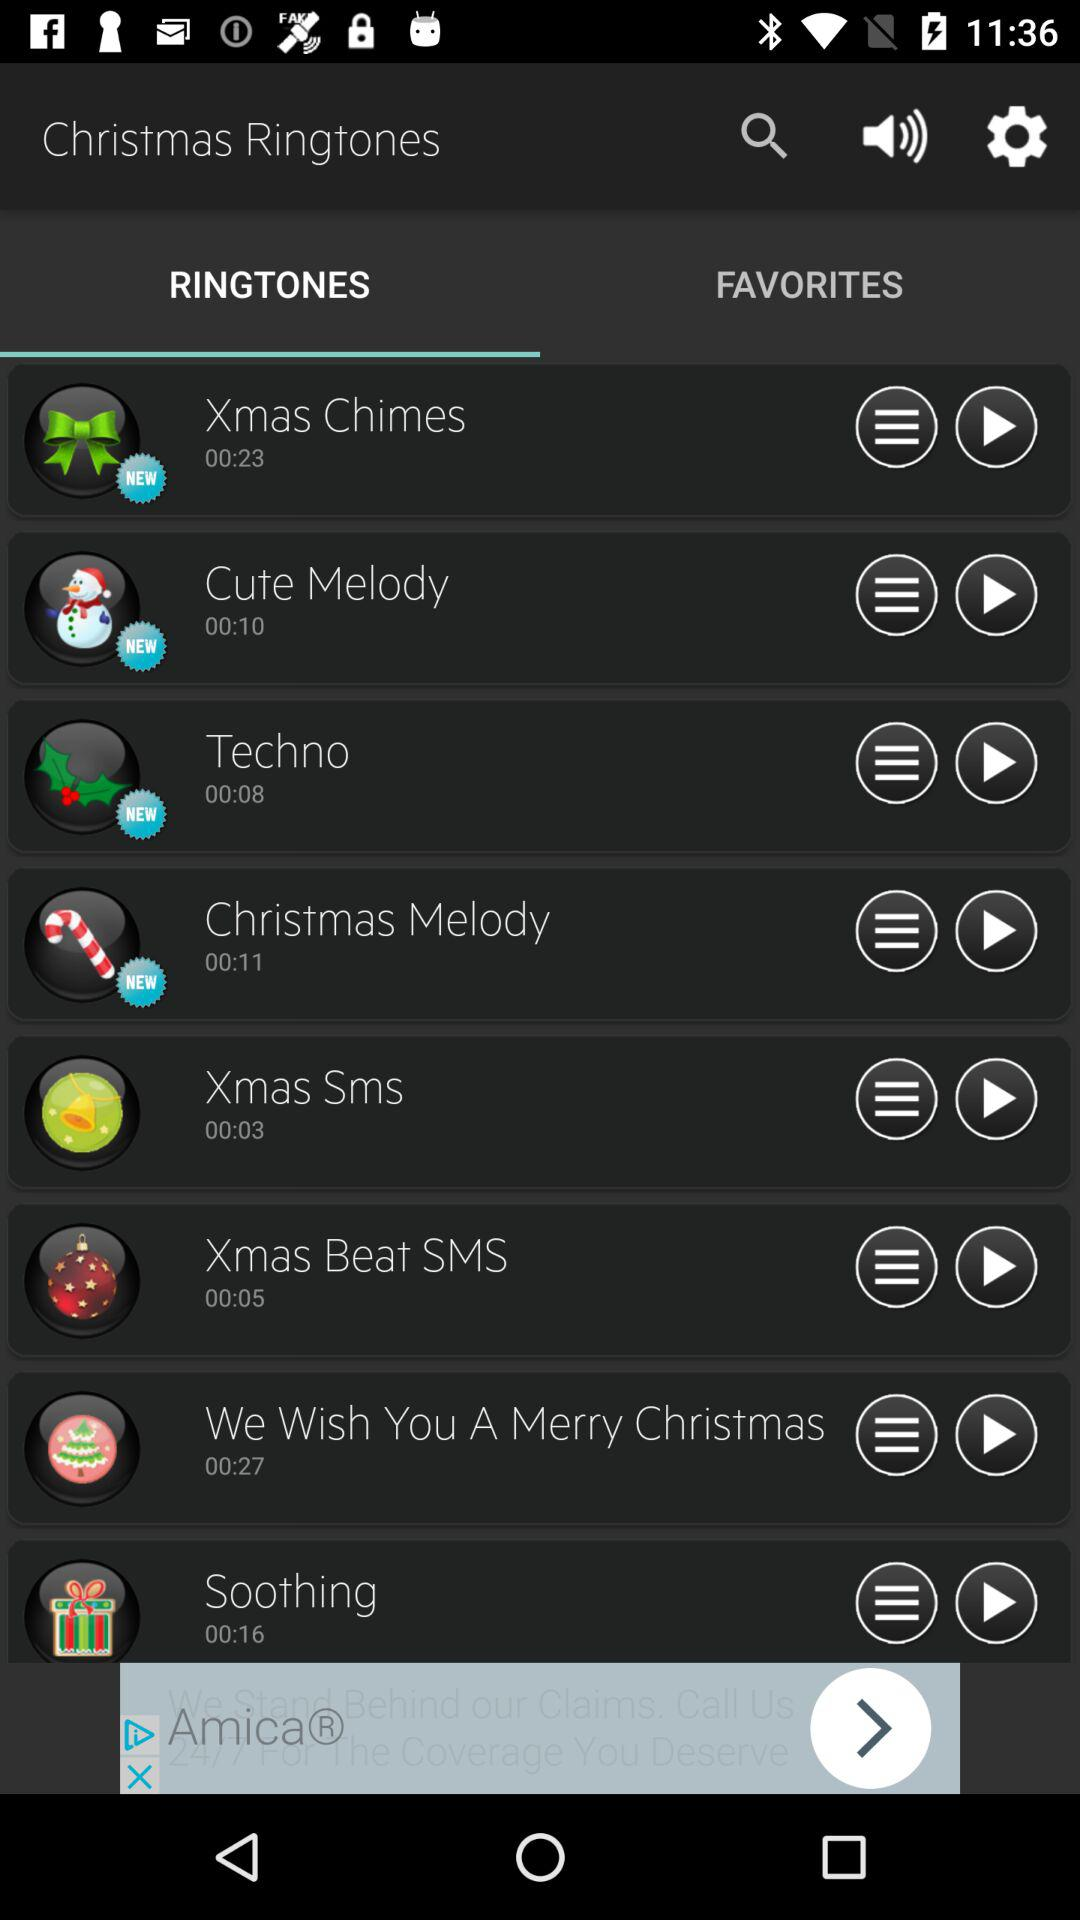Which option is selected for "Christmas Ringtones"? The selected option is "RINGTONES". 